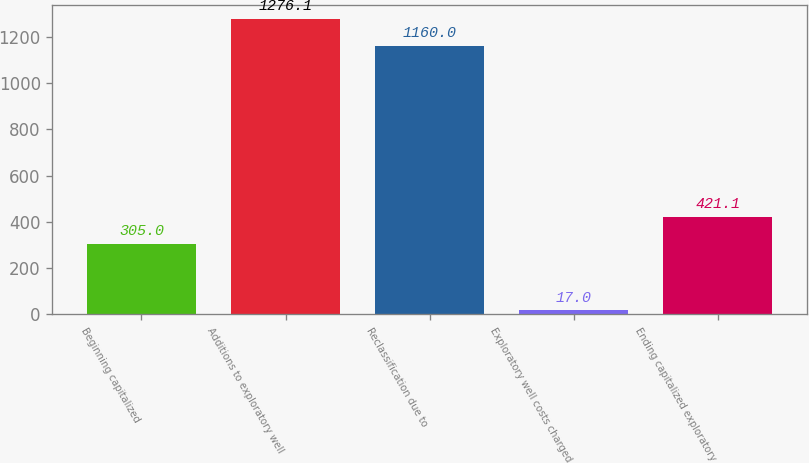Convert chart. <chart><loc_0><loc_0><loc_500><loc_500><bar_chart><fcel>Beginning capitalized<fcel>Additions to exploratory well<fcel>Reclassification due to<fcel>Exploratory well costs charged<fcel>Ending capitalized exploratory<nl><fcel>305<fcel>1276.1<fcel>1160<fcel>17<fcel>421.1<nl></chart> 